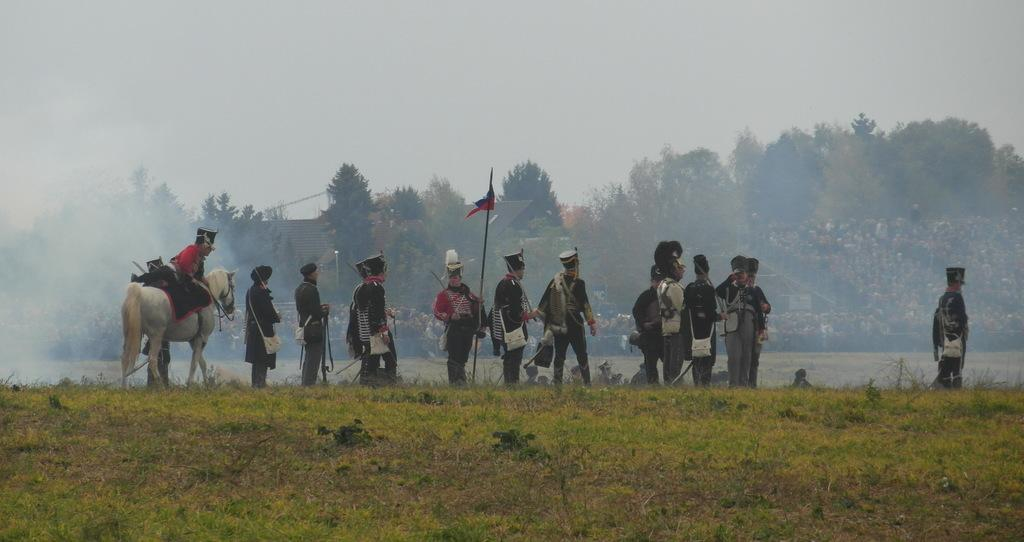What are the persons in the image wearing? The persons in the image are wearing army dress. Where are the persons located in the image? The persons are standing in the ground. What is the man in the image doing? The man is sitting on a white horse in the image. What can be seen in the background of the image? There are trees visible in the background of the image. What type of support can be seen holding up the brick wall in the image? There is no brick wall present in the image. Is the man driving the white horse in the image? The man is sitting on the white horse, but there is no indication that he is driving it, as horses are typically ridden rather than driven. 